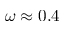Convert formula to latex. <formula><loc_0><loc_0><loc_500><loc_500>\omega \approx 0 . 4</formula> 